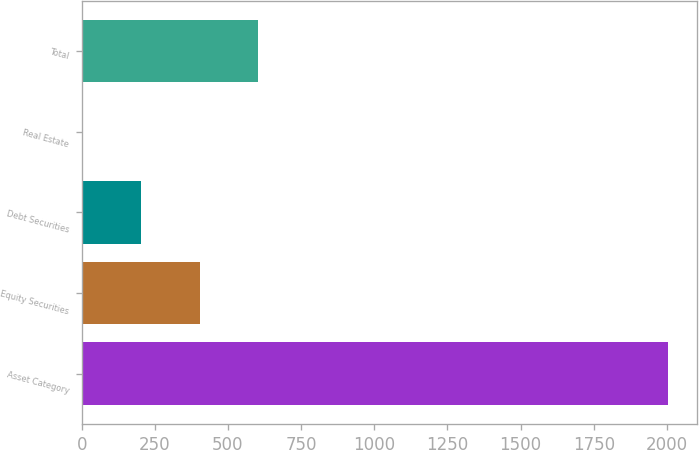<chart> <loc_0><loc_0><loc_500><loc_500><bar_chart><fcel>Asset Category<fcel>Equity Securities<fcel>Debt Securities<fcel>Real Estate<fcel>Total<nl><fcel>2003<fcel>403.8<fcel>203.9<fcel>4<fcel>603.7<nl></chart> 